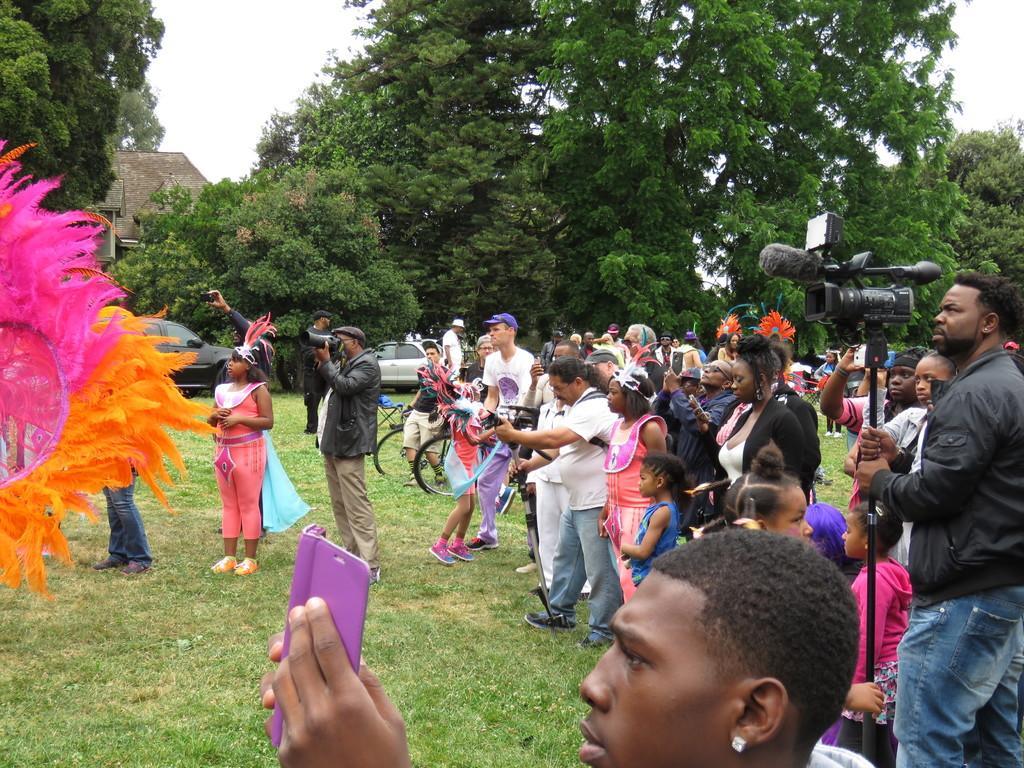How would you summarize this image in a sentence or two? In this image on the right side there are some people who are standing, and there are two persons who are holding cameras and some of them are holding mobile phones and also there are some cycles. At the bottom there is grass and in the background there are some trees, houses and some vehicles, on the left side there are feathers. 